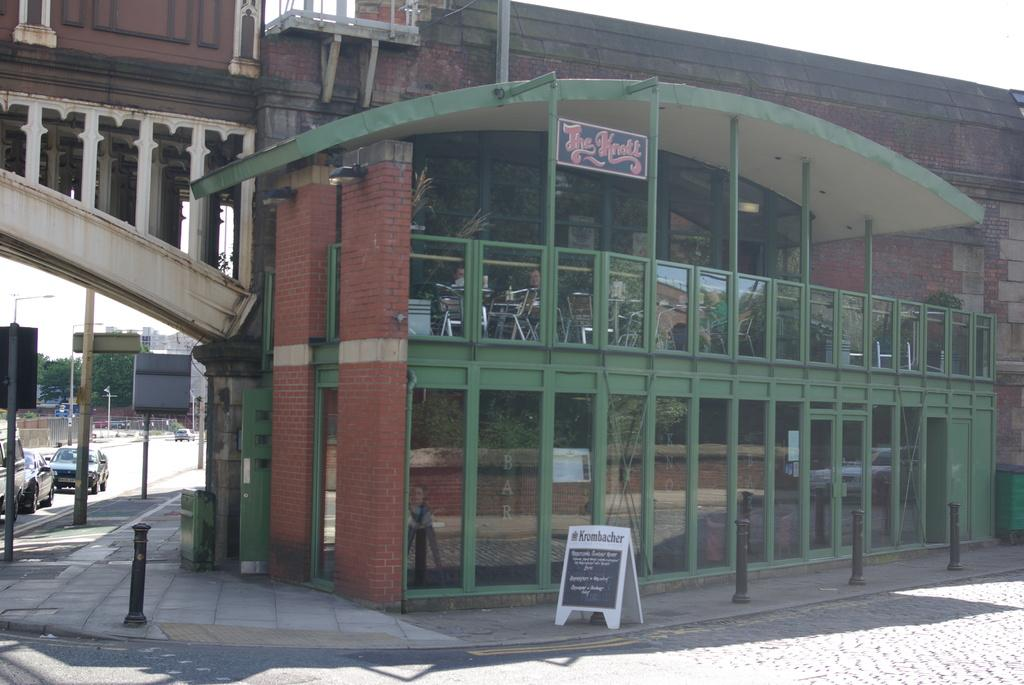What type of structure is visible in the image? There is a building in the image. What is located at the bottom of the image? There is a board at the bottom of the image. What can be seen on the left side of the image? There are cars and poles on the left side of the image. Where is the throne located in the image? There is no throne present in the image. How many chickens can be seen in the image? There are no chickens present in the image. 